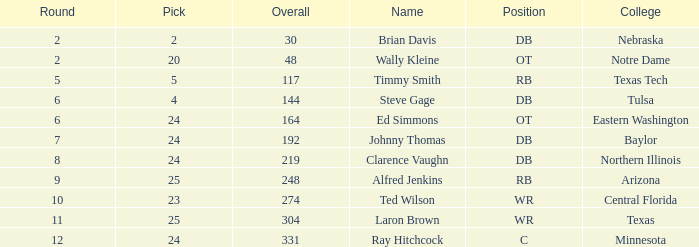I'm looking to parse the entire table for insights. Could you assist me with that? {'header': ['Round', 'Pick', 'Overall', 'Name', 'Position', 'College'], 'rows': [['2', '2', '30', 'Brian Davis', 'DB', 'Nebraska'], ['2', '20', '48', 'Wally Kleine', 'OT', 'Notre Dame'], ['5', '5', '117', 'Timmy Smith', 'RB', 'Texas Tech'], ['6', '4', '144', 'Steve Gage', 'DB', 'Tulsa'], ['6', '24', '164', 'Ed Simmons', 'OT', 'Eastern Washington'], ['7', '24', '192', 'Johnny Thomas', 'DB', 'Baylor'], ['8', '24', '219', 'Clarence Vaughn', 'DB', 'Northern Illinois'], ['9', '25', '248', 'Alfred Jenkins', 'RB', 'Arizona'], ['10', '23', '274', 'Ted Wilson', 'WR', 'Central Florida'], ['11', '25', '304', 'Laron Brown', 'WR', 'Texas'], ['12', '24', '331', 'Ray Hitchcock', 'C', 'Minnesota']]} What are the total rounds for the texas college and has a pick smaller than 25? 0.0. 